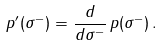Convert formula to latex. <formula><loc_0><loc_0><loc_500><loc_500>\, p ^ { \prime } ( \sigma ^ { - } ) = \frac { d } { d \sigma ^ { - } } \, p ( \sigma ^ { - } ) \, .</formula> 